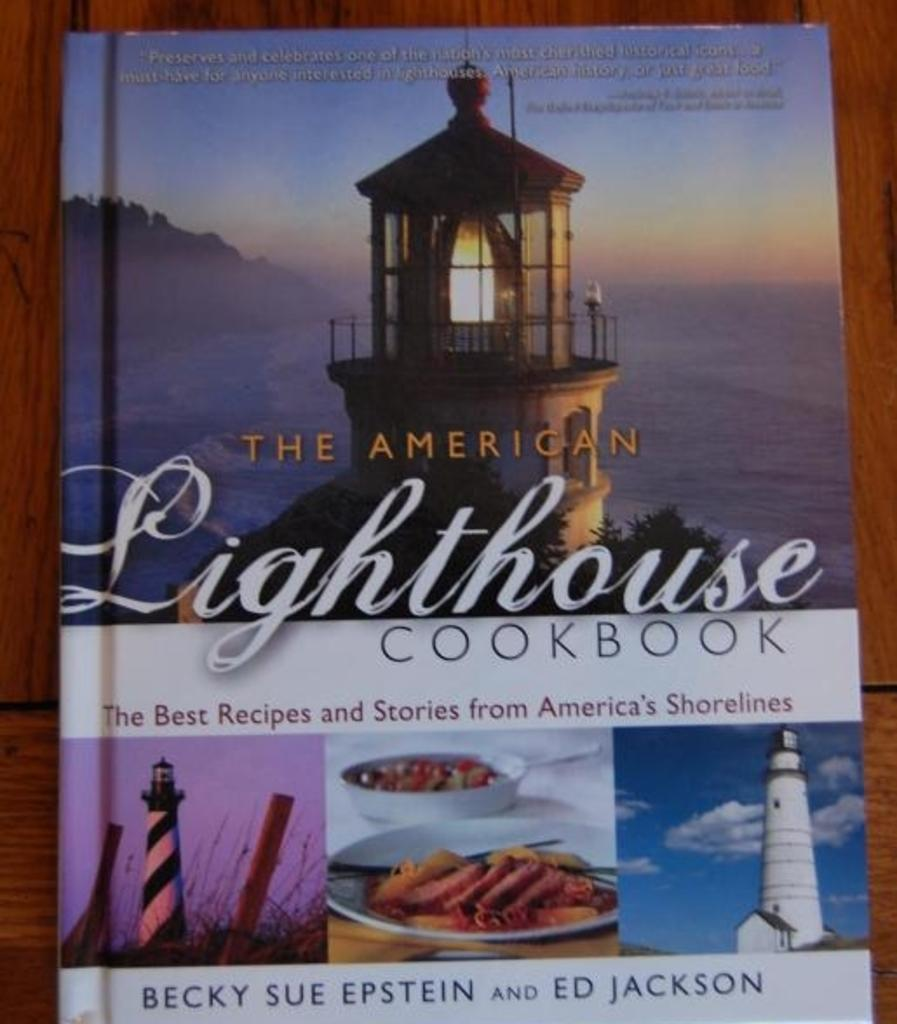Provide a one-sentence caption for the provided image. A cookbook from America with the best receipes and stories from America. 